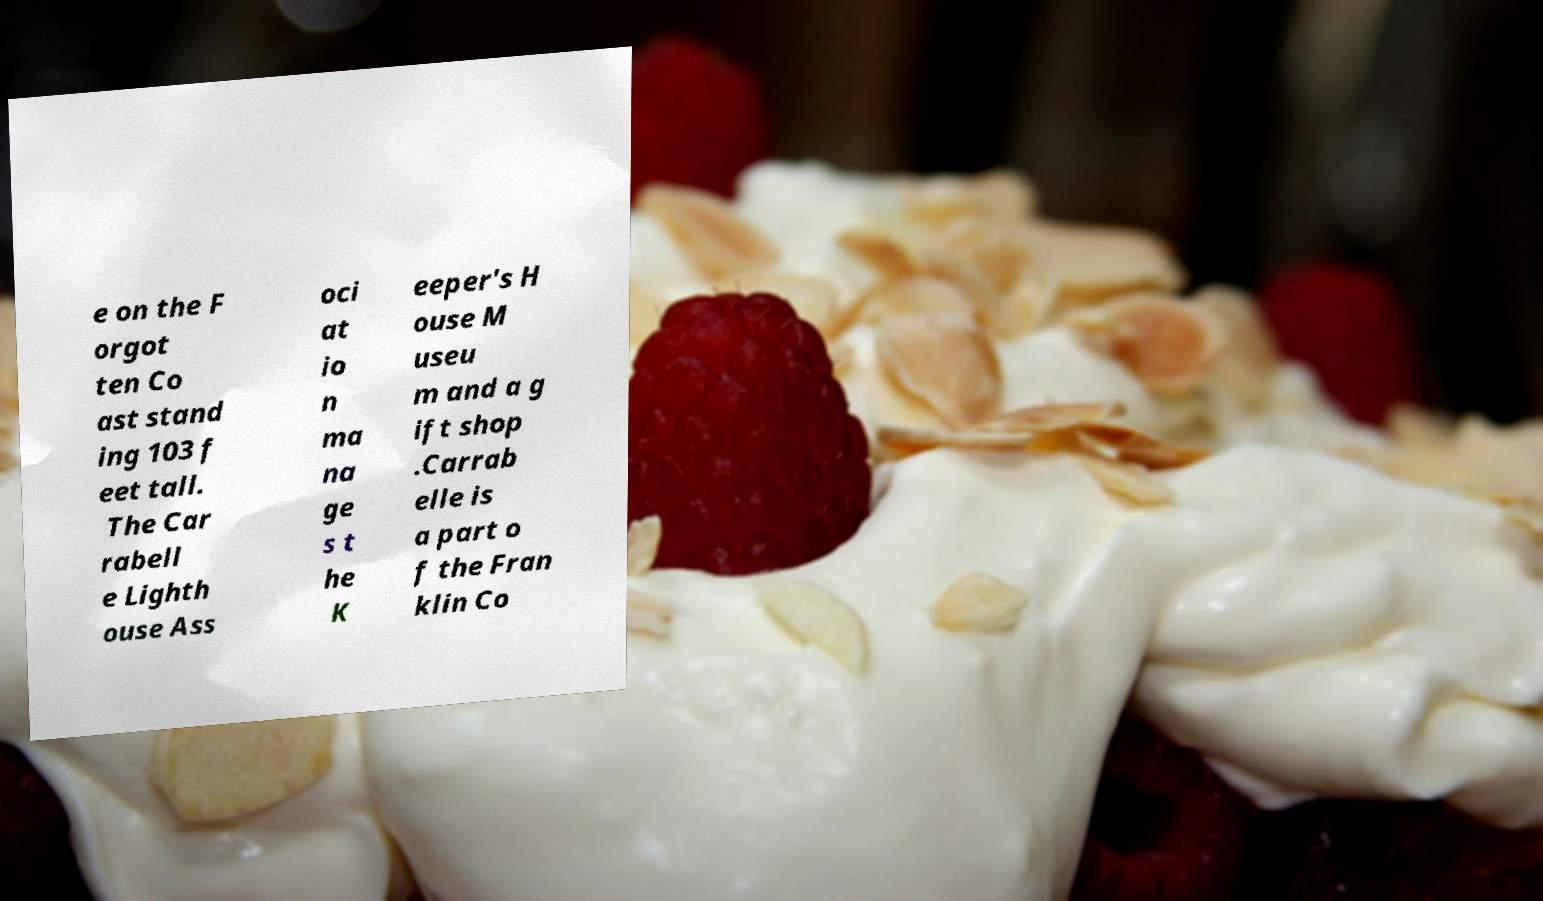Can you read and provide the text displayed in the image?This photo seems to have some interesting text. Can you extract and type it out for me? e on the F orgot ten Co ast stand ing 103 f eet tall. The Car rabell e Lighth ouse Ass oci at io n ma na ge s t he K eeper's H ouse M useu m and a g ift shop .Carrab elle is a part o f the Fran klin Co 